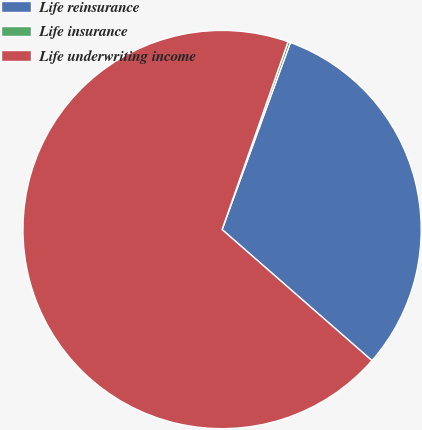Convert chart. <chart><loc_0><loc_0><loc_500><loc_500><pie_chart><fcel>Life reinsurance<fcel>Life insurance<fcel>Life underwriting income<nl><fcel>30.86%<fcel>0.2%<fcel>68.94%<nl></chart> 